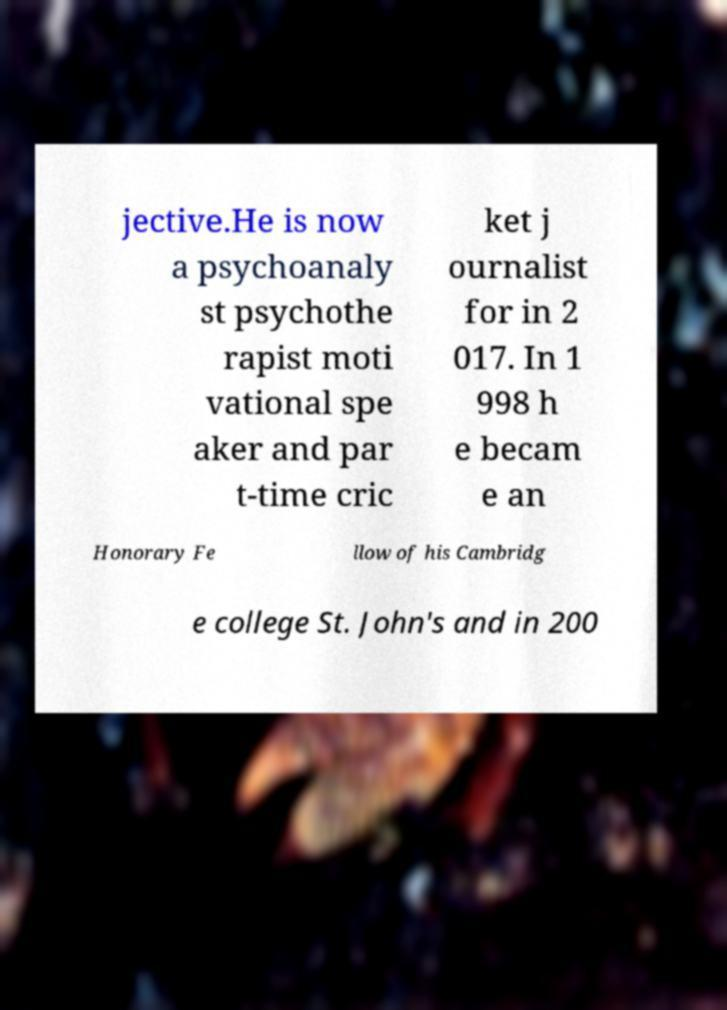For documentation purposes, I need the text within this image transcribed. Could you provide that? jective.He is now a psychoanaly st psychothe rapist moti vational spe aker and par t-time cric ket j ournalist for in 2 017. In 1 998 h e becam e an Honorary Fe llow of his Cambridg e college St. John's and in 200 